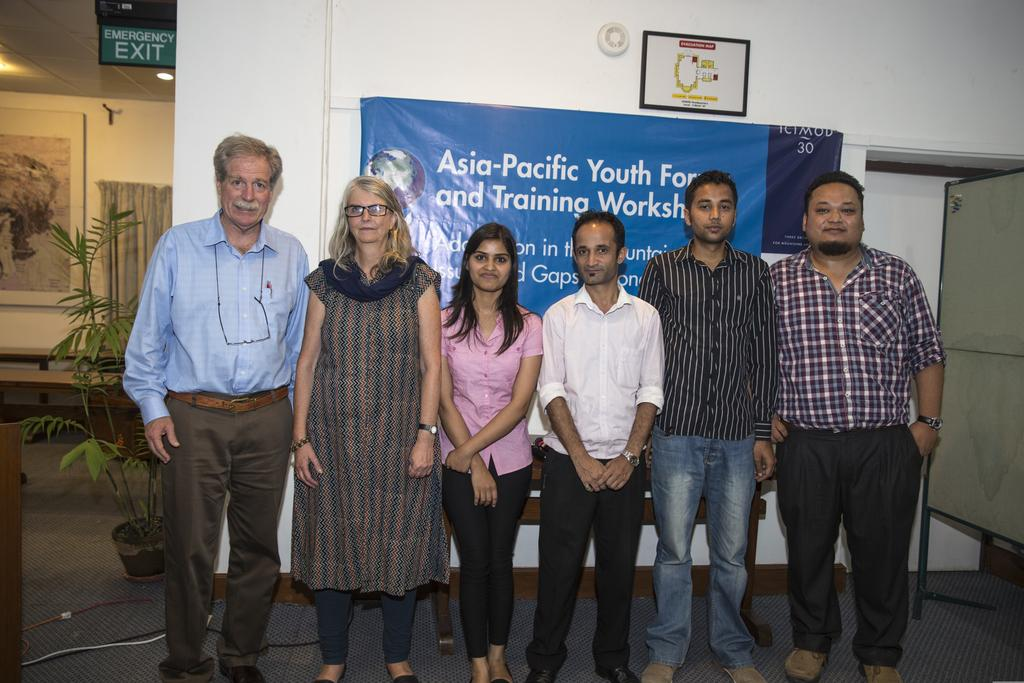What can be seen in the image? There is a group of people in the image. Where is the plant located in the image? The plant is on the left side of the image. What is written on the wall in the background of the image? There is text written on a wall in the background of the image. What is inside the drawer in the image? There is no drawer present in the image. 